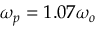<formula> <loc_0><loc_0><loc_500><loc_500>\omega _ { p } = 1 . 0 7 \omega _ { o }</formula> 